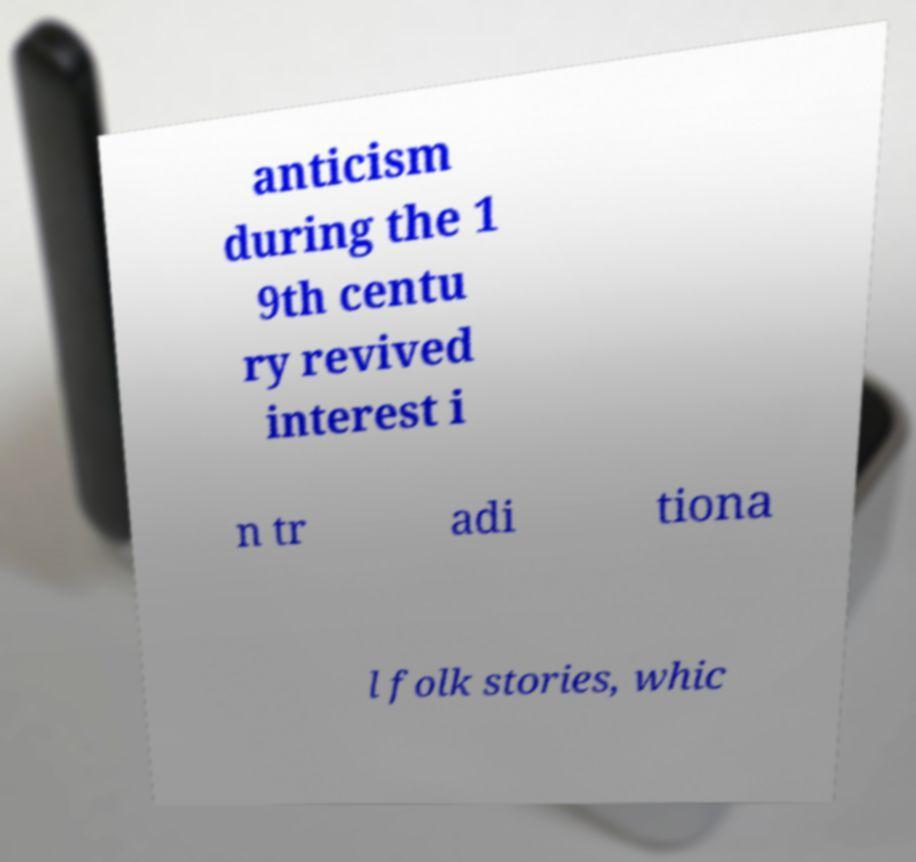There's text embedded in this image that I need extracted. Can you transcribe it verbatim? anticism during the 1 9th centu ry revived interest i n tr adi tiona l folk stories, whic 